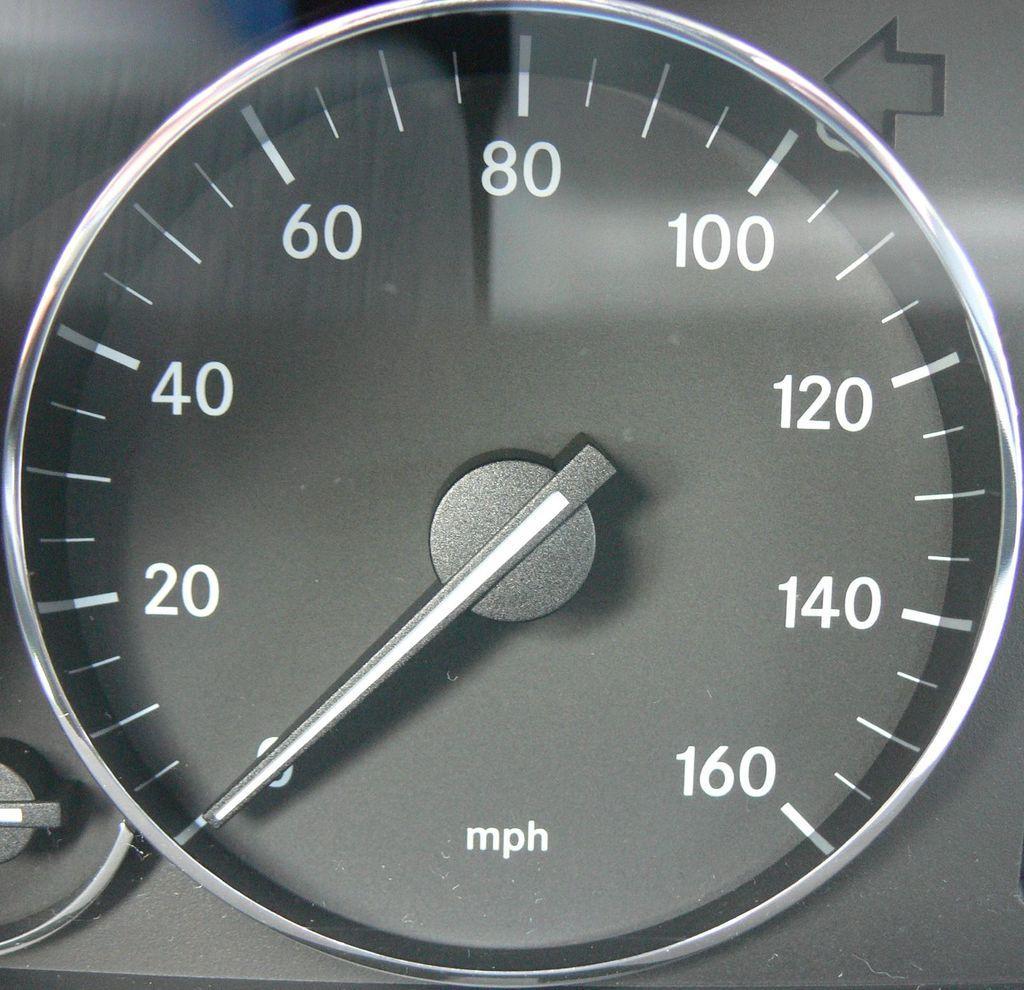How would you summarize this image in a sentence or two? In this picture we can see a speedometer, direction symbol and some objects. 